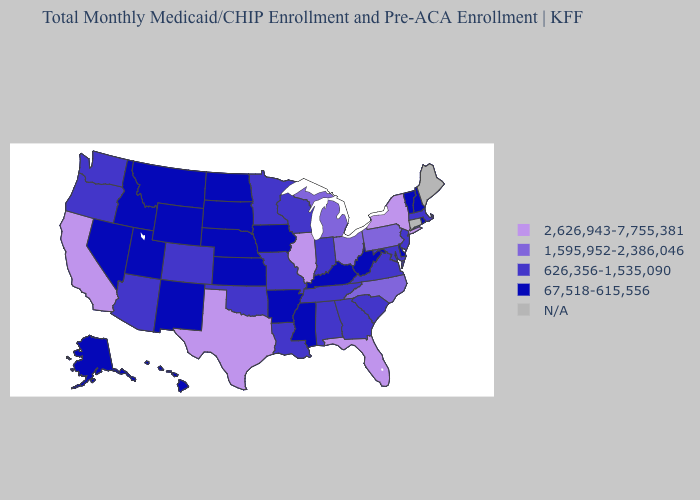What is the value of Michigan?
Concise answer only. 1,595,952-2,386,046. What is the lowest value in states that border Delaware?
Keep it brief. 626,356-1,535,090. Among the states that border Alabama , which have the highest value?
Keep it brief. Florida. Which states have the lowest value in the MidWest?
Answer briefly. Iowa, Kansas, Nebraska, North Dakota, South Dakota. Name the states that have a value in the range 1,595,952-2,386,046?
Write a very short answer. Michigan, North Carolina, Ohio, Pennsylvania. Among the states that border Wyoming , does Utah have the lowest value?
Give a very brief answer. Yes. Name the states that have a value in the range N/A?
Quick response, please. Connecticut, Maine. Name the states that have a value in the range 1,595,952-2,386,046?
Keep it brief. Michigan, North Carolina, Ohio, Pennsylvania. What is the value of Montana?
Keep it brief. 67,518-615,556. Does the map have missing data?
Keep it brief. Yes. Name the states that have a value in the range 2,626,943-7,755,381?
Write a very short answer. California, Florida, Illinois, New York, Texas. Name the states that have a value in the range N/A?
Quick response, please. Connecticut, Maine. Name the states that have a value in the range 626,356-1,535,090?
Short answer required. Alabama, Arizona, Colorado, Georgia, Indiana, Louisiana, Maryland, Massachusetts, Minnesota, Missouri, New Jersey, Oklahoma, Oregon, South Carolina, Tennessee, Virginia, Washington, Wisconsin. 